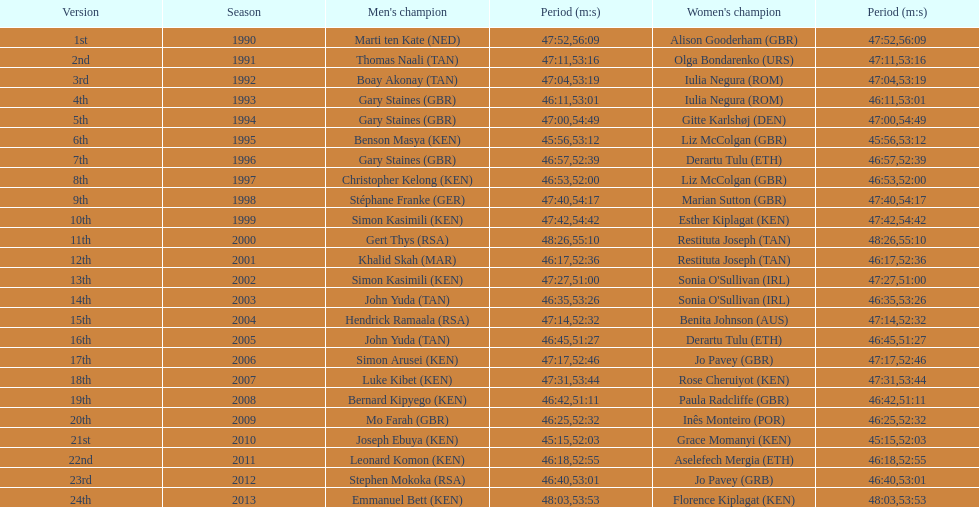How long did sonia o'sullivan take to finish in 2003? 53:26. 